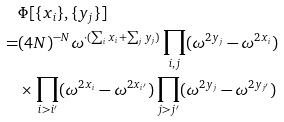Convert formula to latex. <formula><loc_0><loc_0><loc_500><loc_500>& \Phi [ \{ x _ { i } \} , \{ y _ { j } \} ] \\ = & ( 4 N ) ^ { - N } \omega ^ { \cdot ( \sum _ { i } x _ { i } + \sum _ { j } y _ { j } ) } \prod _ { i , j } ( \omega ^ { 2 y _ { j } } - \omega ^ { 2 x _ { i } } ) \\ & \times \prod _ { i > i ^ { \prime } } ( \omega ^ { 2 x _ { i } } - \omega ^ { 2 x _ { i ^ { \prime } } } ) \prod _ { j > j ^ { \prime } } ( \omega ^ { 2 y _ { j } } - \omega ^ { 2 y _ { j ^ { \prime } } } )</formula> 